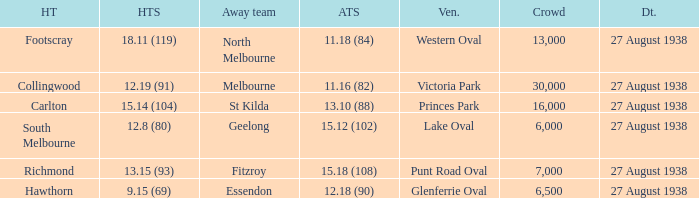Which home team had the away team score 15.18 (108) against them? 13.15 (93). 